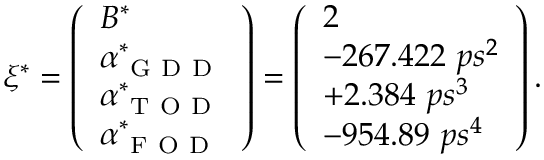<formula> <loc_0><loc_0><loc_500><loc_500>\xi ^ { * } = \left ( \begin{array} { l } { B ^ { * } } \\ { \alpha _ { G D D } ^ { * } } \\ { \alpha _ { T O D } ^ { * } } \\ { \alpha _ { F O D } ^ { * } } \end{array} \right ) = \left ( \begin{array} { l } { 2 } \\ { - 2 6 7 . 4 2 2 \ p s ^ { 2 } } \\ { + 2 . 3 8 4 \ p s ^ { 3 } } \\ { - 9 5 4 . 8 9 \ p s ^ { 4 } } \end{array} \right ) .</formula> 